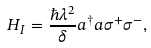<formula> <loc_0><loc_0><loc_500><loc_500>H _ { I } = \frac { \hbar { \lambda } ^ { 2 } } { \delta } a ^ { \dagger } a \sigma ^ { + } \sigma ^ { - } ,</formula> 